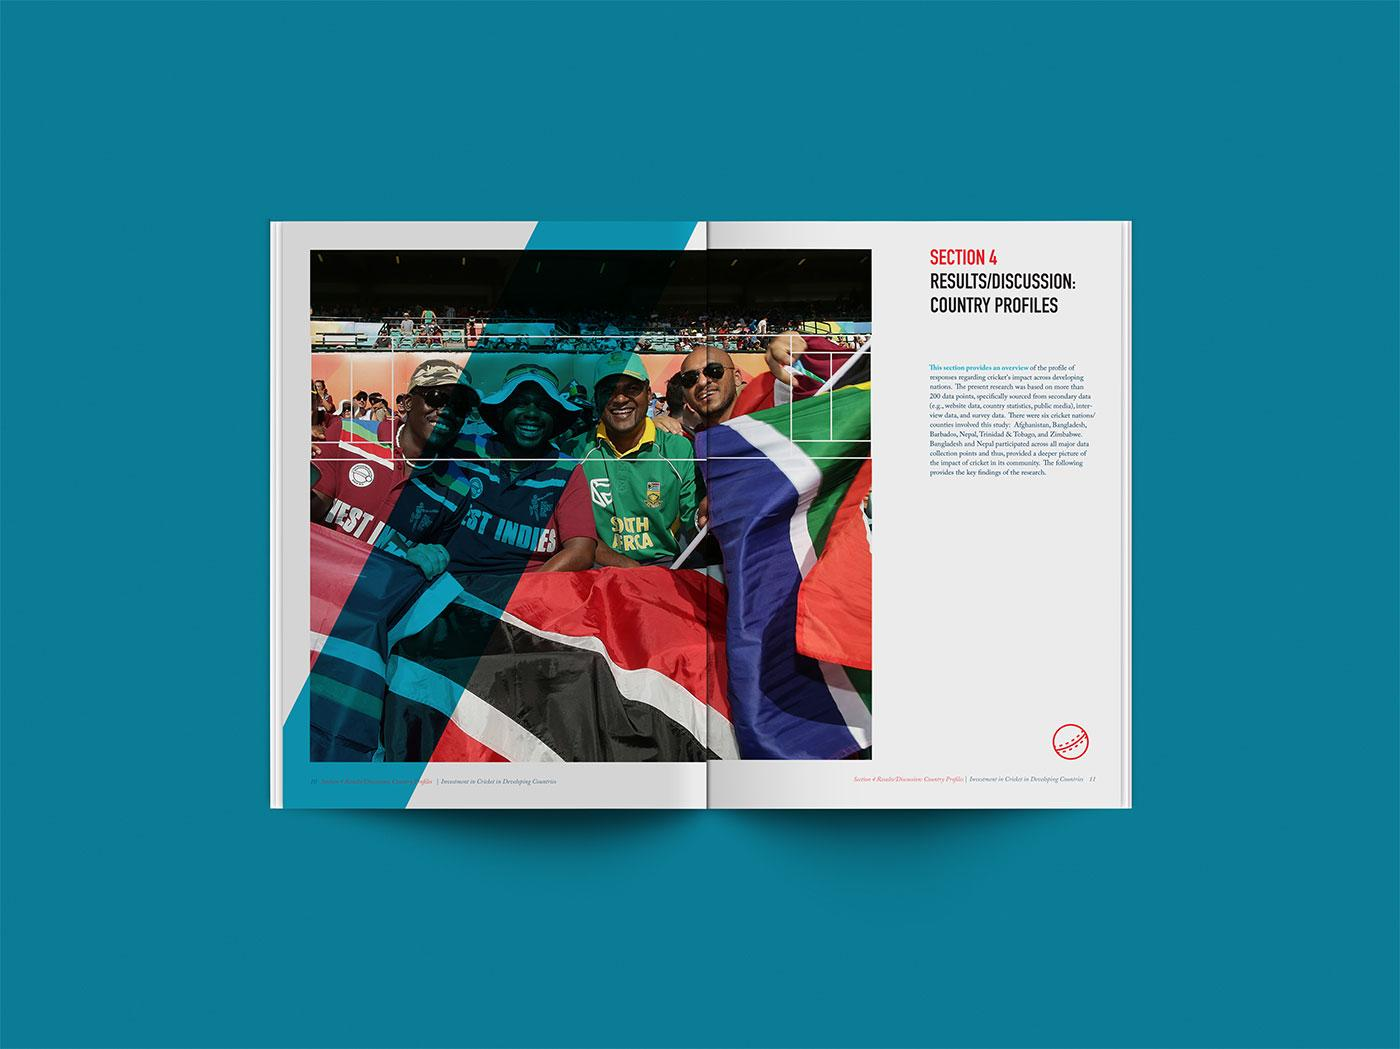Outline some significant characteristics in this image. The names of countries such as West Indies and South Africa are found on the banyan tree. 